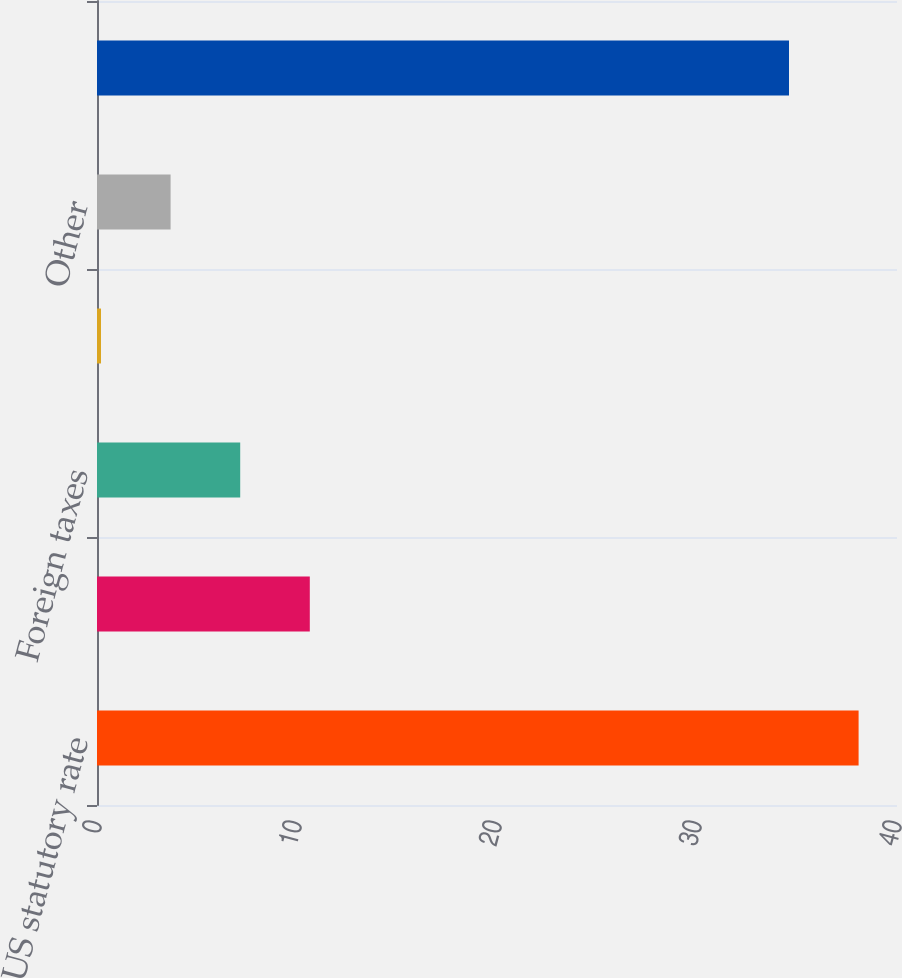Convert chart. <chart><loc_0><loc_0><loc_500><loc_500><bar_chart><fcel>US statutory rate<fcel>State taxes net of federal tax<fcel>Foreign taxes<fcel>Valuation allowances<fcel>Other<fcel>Total Provision for income<nl><fcel>38.08<fcel>10.64<fcel>7.16<fcel>0.2<fcel>3.68<fcel>34.6<nl></chart> 